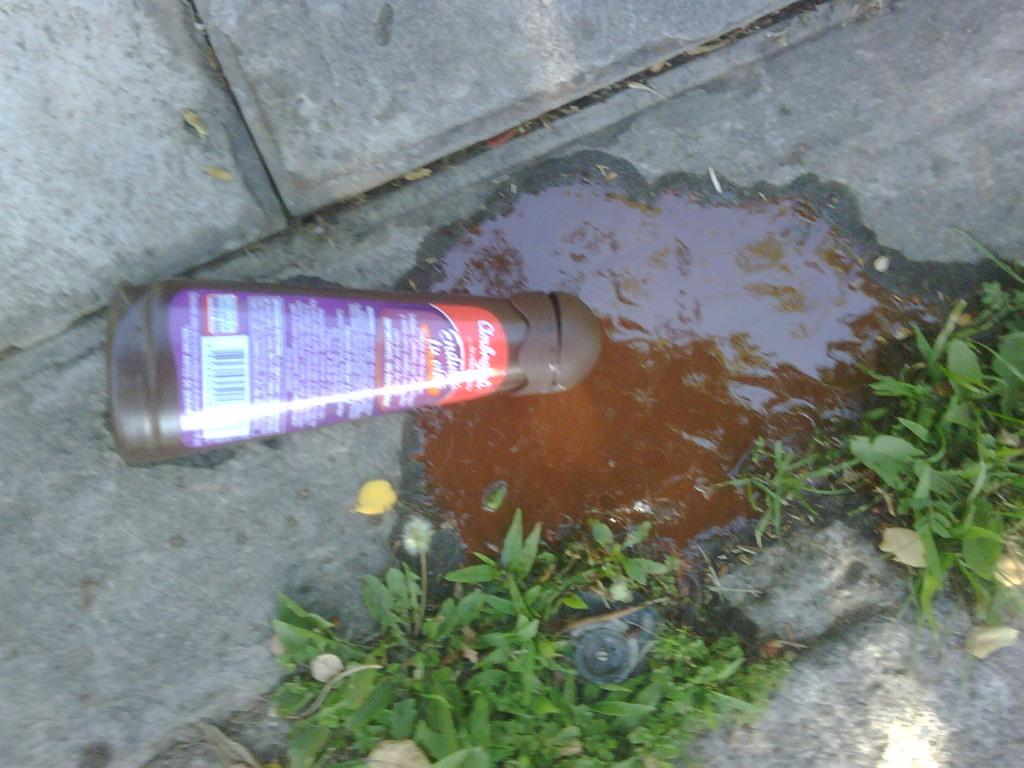What is the main object in the center of the image? There is a bottle in the center of the image. Where is the bottle located? The bottle is on the floor. What is happening with the bottle in the image? Liquid is coming out of the bottle. How does the liquid appear in the image? The liquid is spread over the floor. What type of environment is depicted in the image? There is grass visible in the image, suggesting an outdoor setting. What type of impulse can be seen affecting the lawyer in the image? There is no lawyer or impulse present in the image; it features a bottle with liquid on the floor in an outdoor setting. How does the fog affect the visibility in the image? There is no fog present in the image; it is a clear outdoor scene with grass and a bottle on the floor. 